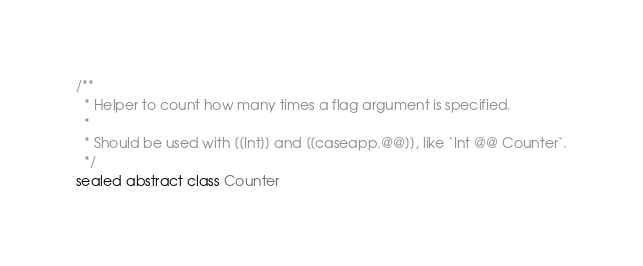Convert code to text. <code><loc_0><loc_0><loc_500><loc_500><_Scala_>/**
  * Helper to count how many times a flag argument is specified.
  *
  * Should be used with [[Int]] and [[caseapp.@@]], like `Int @@ Counter`.
  */
sealed abstract class Counter
</code> 